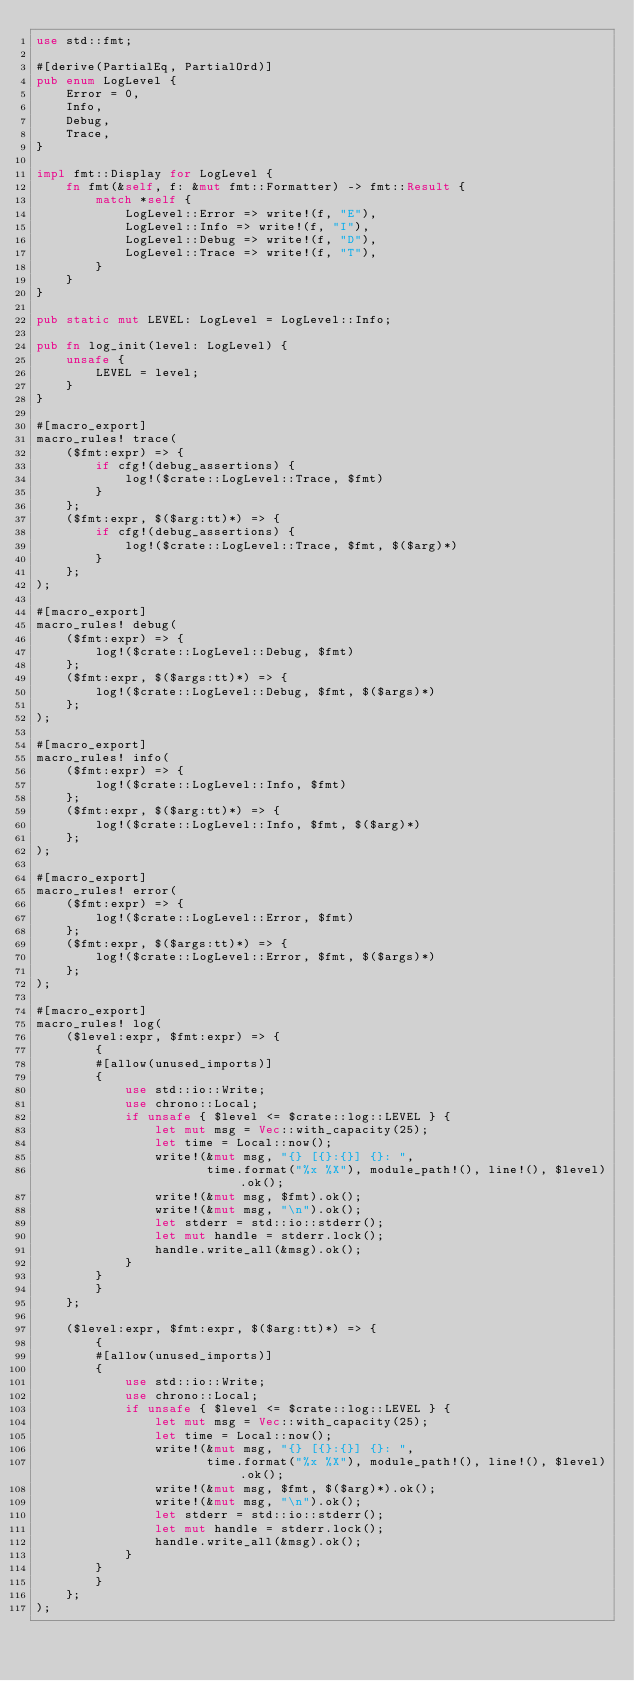<code> <loc_0><loc_0><loc_500><loc_500><_Rust_>use std::fmt;

#[derive(PartialEq, PartialOrd)]
pub enum LogLevel {
    Error = 0,
    Info,
    Debug,
    Trace,
}

impl fmt::Display for LogLevel {
    fn fmt(&self, f: &mut fmt::Formatter) -> fmt::Result {
        match *self {
            LogLevel::Error => write!(f, "E"),
            LogLevel::Info => write!(f, "I"),
            LogLevel::Debug => write!(f, "D"),
            LogLevel::Trace => write!(f, "T"),
        }
    }
}

pub static mut LEVEL: LogLevel = LogLevel::Info;

pub fn log_init(level: LogLevel) {
    unsafe {
        LEVEL = level;
    }
}

#[macro_export]
macro_rules! trace(
    ($fmt:expr) => {
        if cfg!(debug_assertions) {
            log!($crate::LogLevel::Trace, $fmt)
        }
    };
    ($fmt:expr, $($arg:tt)*) => {
        if cfg!(debug_assertions) {
            log!($crate::LogLevel::Trace, $fmt, $($arg)*)
        }
    };
);

#[macro_export]
macro_rules! debug(
    ($fmt:expr) => {
        log!($crate::LogLevel::Debug, $fmt)
    };
    ($fmt:expr, $($args:tt)*) => {
        log!($crate::LogLevel::Debug, $fmt, $($args)*)
    };
);

#[macro_export]
macro_rules! info(
    ($fmt:expr) => {
        log!($crate::LogLevel::Info, $fmt)
    };
    ($fmt:expr, $($arg:tt)*) => {
        log!($crate::LogLevel::Info, $fmt, $($arg)*)
    };
);

#[macro_export]
macro_rules! error(
    ($fmt:expr) => {
        log!($crate::LogLevel::Error, $fmt)
    };
    ($fmt:expr, $($args:tt)*) => {
        log!($crate::LogLevel::Error, $fmt, $($args)*)
    };
);

#[macro_export]
macro_rules! log(
    ($level:expr, $fmt:expr) => {
        {
        #[allow(unused_imports)]
        {
            use std::io::Write;
            use chrono::Local;
            if unsafe { $level <= $crate::log::LEVEL } {
                let mut msg = Vec::with_capacity(25);
                let time = Local::now();
                write!(&mut msg, "{} [{}:{}] {}: ",
                       time.format("%x %X"), module_path!(), line!(), $level).ok();
                write!(&mut msg, $fmt).ok();
                write!(&mut msg, "\n").ok();
                let stderr = std::io::stderr();
                let mut handle = stderr.lock();
                handle.write_all(&msg).ok();
            }
        }
        }
    };

    ($level:expr, $fmt:expr, $($arg:tt)*) => {
        {
        #[allow(unused_imports)]
        {
            use std::io::Write;
            use chrono::Local;
            if unsafe { $level <= $crate::log::LEVEL } {
                let mut msg = Vec::with_capacity(25);
                let time = Local::now();
                write!(&mut msg, "{} [{}:{}] {}: ",
                       time.format("%x %X"), module_path!(), line!(), $level).ok();
                write!(&mut msg, $fmt, $($arg)*).ok();
                write!(&mut msg, "\n").ok();
                let stderr = std::io::stderr();
                let mut handle = stderr.lock();
                handle.write_all(&msg).ok();
            }
        }
        }
    };
);
</code> 